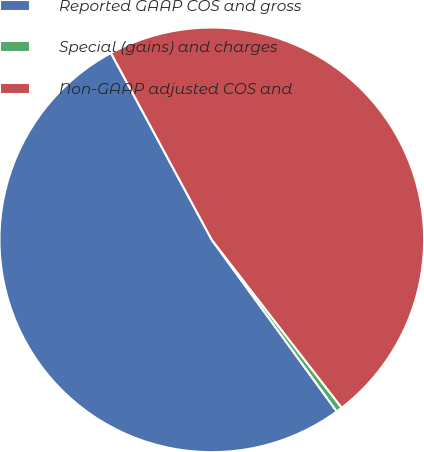Convert chart to OTSL. <chart><loc_0><loc_0><loc_500><loc_500><pie_chart><fcel>Reported GAAP COS and gross<fcel>Special (gains) and charges<fcel>Non-GAAP adjusted COS and<nl><fcel>52.14%<fcel>0.46%<fcel>47.4%<nl></chart> 